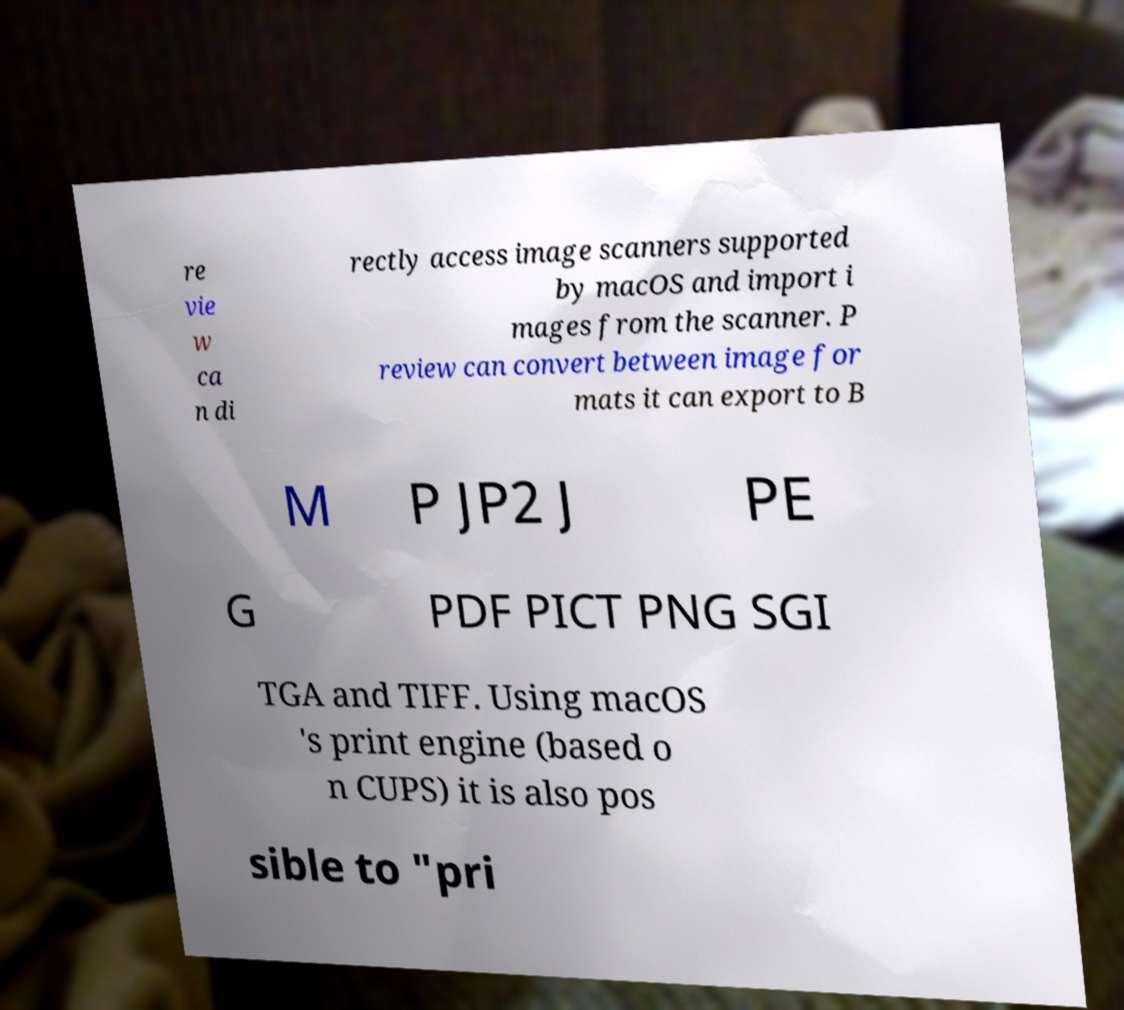Could you assist in decoding the text presented in this image and type it out clearly? re vie w ca n di rectly access image scanners supported by macOS and import i mages from the scanner. P review can convert between image for mats it can export to B M P JP2 J PE G PDF PICT PNG SGI TGA and TIFF. Using macOS 's print engine (based o n CUPS) it is also pos sible to "pri 